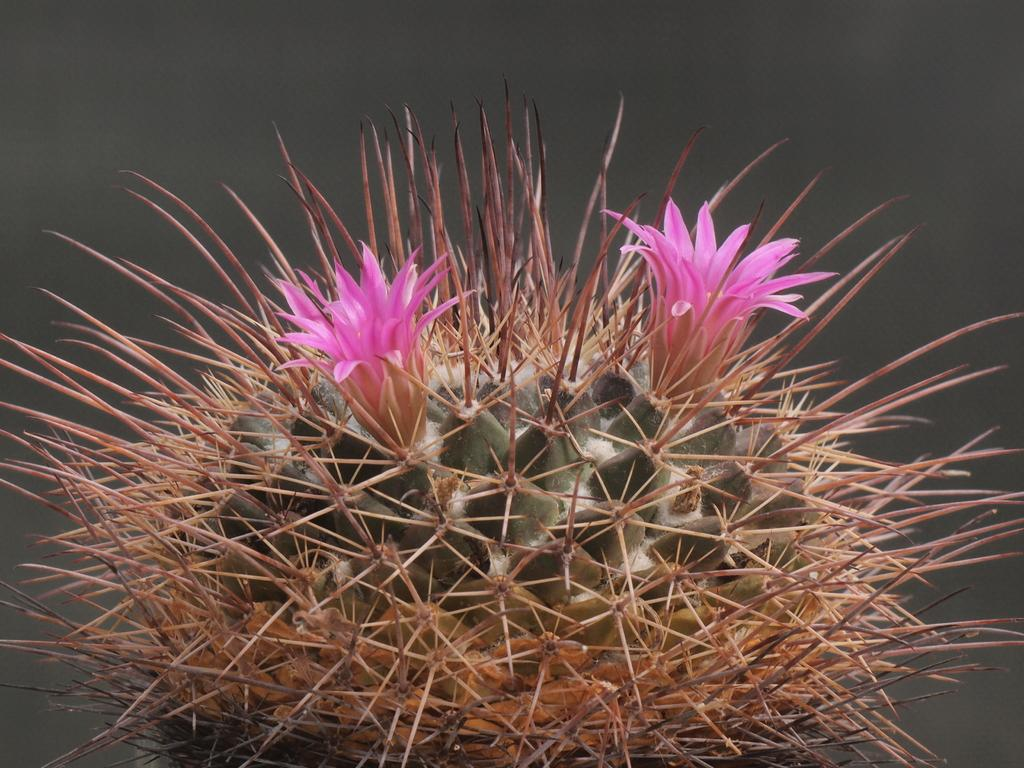What type of plant is in the image? There is an Echinocereus plant in the image. How many flowers are on the plant? The plant has two flowers on it. What is the star's degree of influence on the plant in the image? There is no star present in the image, so it cannot have any influence on the plant. 